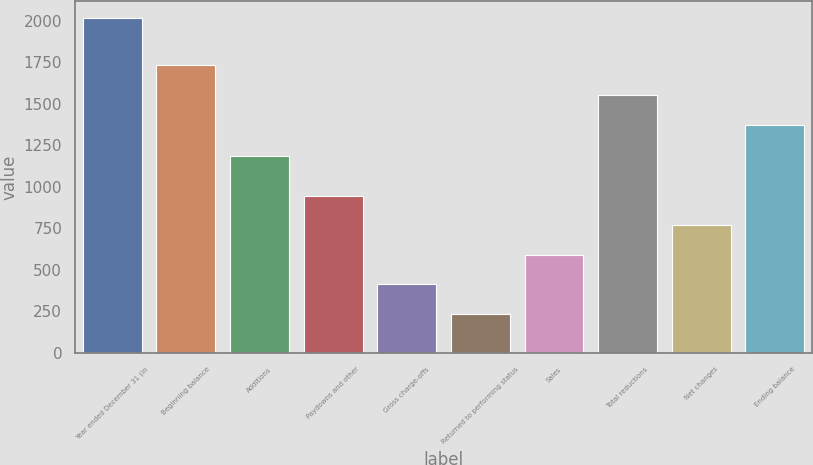Convert chart. <chart><loc_0><loc_0><loc_500><loc_500><bar_chart><fcel>Year ended December 31 (in<fcel>Beginning balance<fcel>Additions<fcel>Paydowns and other<fcel>Gross charge-offs<fcel>Returned to performing status<fcel>Sales<fcel>Total reductions<fcel>Net changes<fcel>Ending balance<nl><fcel>2018<fcel>1734<fcel>1188<fcel>947.6<fcel>412.4<fcel>234<fcel>590.8<fcel>1552<fcel>769.2<fcel>1370<nl></chart> 